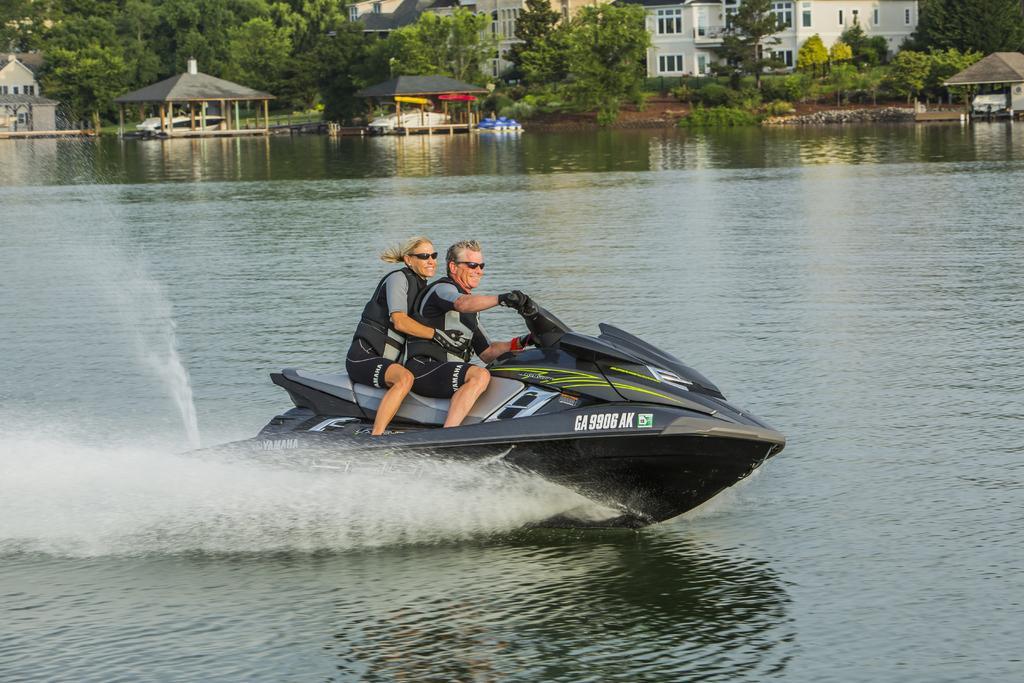Can you describe this image briefly? In this image I can see a two person sitting on the speedboat. It is in black and ash color. Back I can see buildings,windows,trees and sheds. We can see water. 